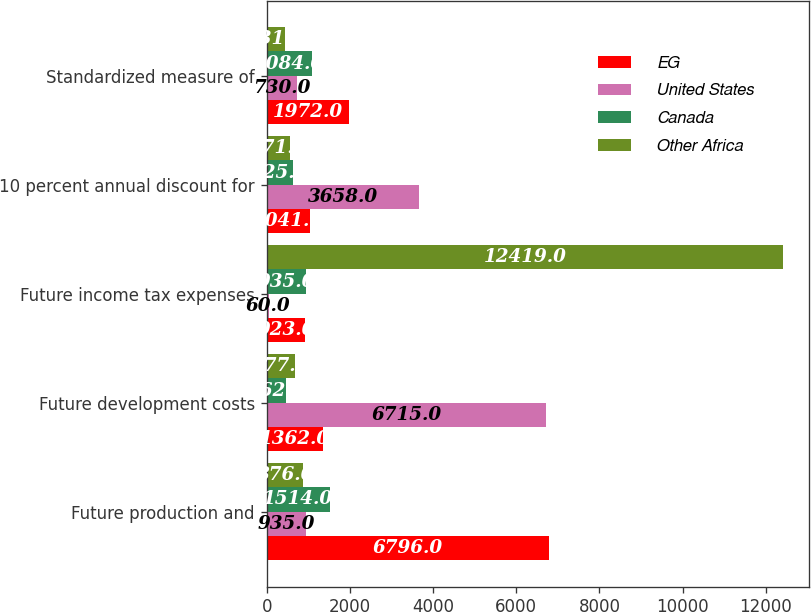<chart> <loc_0><loc_0><loc_500><loc_500><stacked_bar_chart><ecel><fcel>Future production and<fcel>Future development costs<fcel>Future income tax expenses<fcel>10 percent annual discount for<fcel>Standardized measure of<nl><fcel>EG<fcel>6796<fcel>1362<fcel>923<fcel>1041<fcel>1972<nl><fcel>United States<fcel>935<fcel>6715<fcel>60<fcel>3658<fcel>730<nl><fcel>Canada<fcel>1514<fcel>462<fcel>935<fcel>625<fcel>1084<nl><fcel>Other Africa<fcel>876<fcel>677<fcel>12419<fcel>571<fcel>431<nl></chart> 